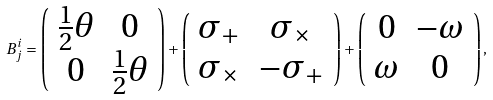Convert formula to latex. <formula><loc_0><loc_0><loc_500><loc_500>B ^ { i } _ { j } = \left ( \begin{array} { c c } \frac { 1 } { 2 } \theta & 0 \\ 0 & \frac { 1 } { 2 } \theta \\ \end{array} \right ) + \left ( \begin{array} { c c } \sigma _ { + } & \sigma _ { \times } \\ \sigma _ { \times } & - \sigma _ { + } \\ \end{array} \right ) + \left ( \begin{array} { c c } 0 & - \omega \\ \omega & 0 \\ \end{array} \right ) ,</formula> 